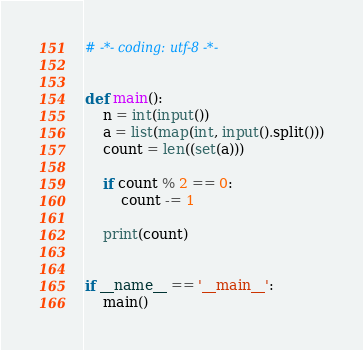Convert code to text. <code><loc_0><loc_0><loc_500><loc_500><_Python_># -*- coding: utf-8 -*-


def main():
    n = int(input())
    a = list(map(int, input().split()))
    count = len((set(a)))

    if count % 2 == 0:
        count -= 1

    print(count)


if __name__ == '__main__':
    main()
</code> 